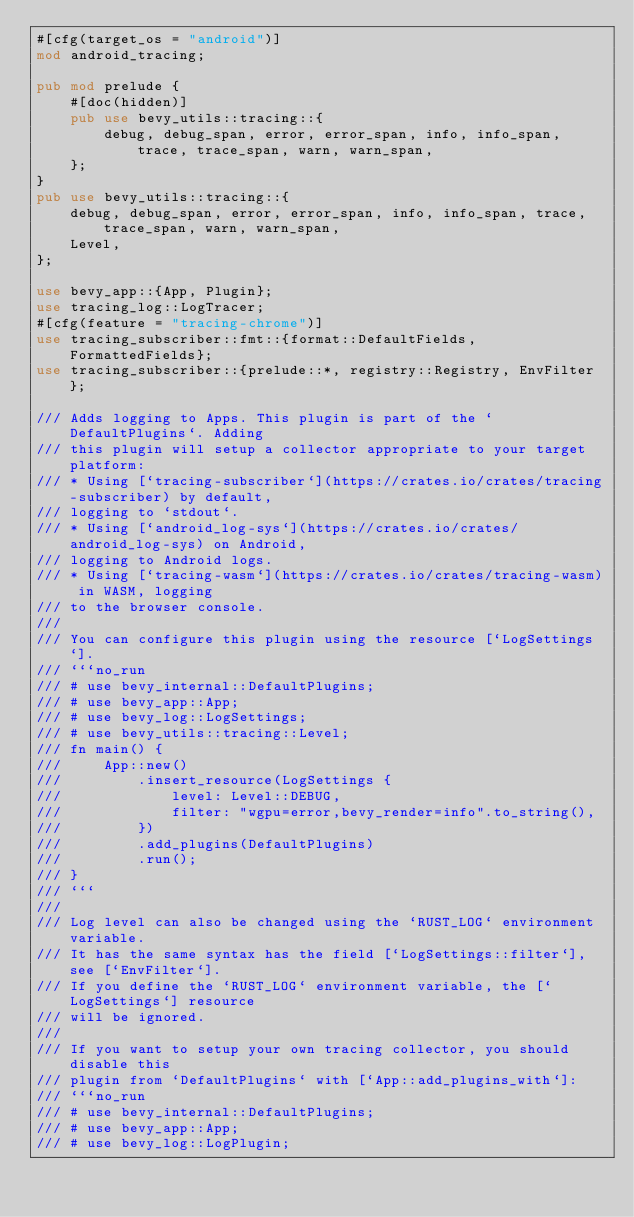Convert code to text. <code><loc_0><loc_0><loc_500><loc_500><_Rust_>#[cfg(target_os = "android")]
mod android_tracing;

pub mod prelude {
    #[doc(hidden)]
    pub use bevy_utils::tracing::{
        debug, debug_span, error, error_span, info, info_span, trace, trace_span, warn, warn_span,
    };
}
pub use bevy_utils::tracing::{
    debug, debug_span, error, error_span, info, info_span, trace, trace_span, warn, warn_span,
    Level,
};

use bevy_app::{App, Plugin};
use tracing_log::LogTracer;
#[cfg(feature = "tracing-chrome")]
use tracing_subscriber::fmt::{format::DefaultFields, FormattedFields};
use tracing_subscriber::{prelude::*, registry::Registry, EnvFilter};

/// Adds logging to Apps. This plugin is part of the `DefaultPlugins`. Adding
/// this plugin will setup a collector appropriate to your target platform:
/// * Using [`tracing-subscriber`](https://crates.io/crates/tracing-subscriber) by default,
/// logging to `stdout`.
/// * Using [`android_log-sys`](https://crates.io/crates/android_log-sys) on Android,
/// logging to Android logs.
/// * Using [`tracing-wasm`](https://crates.io/crates/tracing-wasm) in WASM, logging
/// to the browser console.
///
/// You can configure this plugin using the resource [`LogSettings`].
/// ```no_run
/// # use bevy_internal::DefaultPlugins;
/// # use bevy_app::App;
/// # use bevy_log::LogSettings;
/// # use bevy_utils::tracing::Level;
/// fn main() {
///     App::new()
///         .insert_resource(LogSettings {
///             level: Level::DEBUG,
///             filter: "wgpu=error,bevy_render=info".to_string(),
///         })
///         .add_plugins(DefaultPlugins)
///         .run();
/// }
/// ```
///
/// Log level can also be changed using the `RUST_LOG` environment variable.
/// It has the same syntax has the field [`LogSettings::filter`], see [`EnvFilter`].
/// If you define the `RUST_LOG` environment variable, the [`LogSettings`] resource
/// will be ignored.
///
/// If you want to setup your own tracing collector, you should disable this
/// plugin from `DefaultPlugins` with [`App::add_plugins_with`]:
/// ```no_run
/// # use bevy_internal::DefaultPlugins;
/// # use bevy_app::App;
/// # use bevy_log::LogPlugin;</code> 